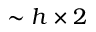Convert formula to latex. <formula><loc_0><loc_0><loc_500><loc_500>\sim h \times 2</formula> 